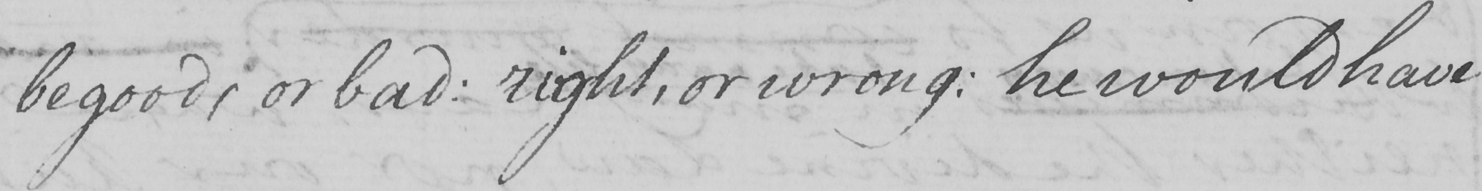Please transcribe the handwritten text in this image. be good , or bad :  right , or wrong :  he would have 